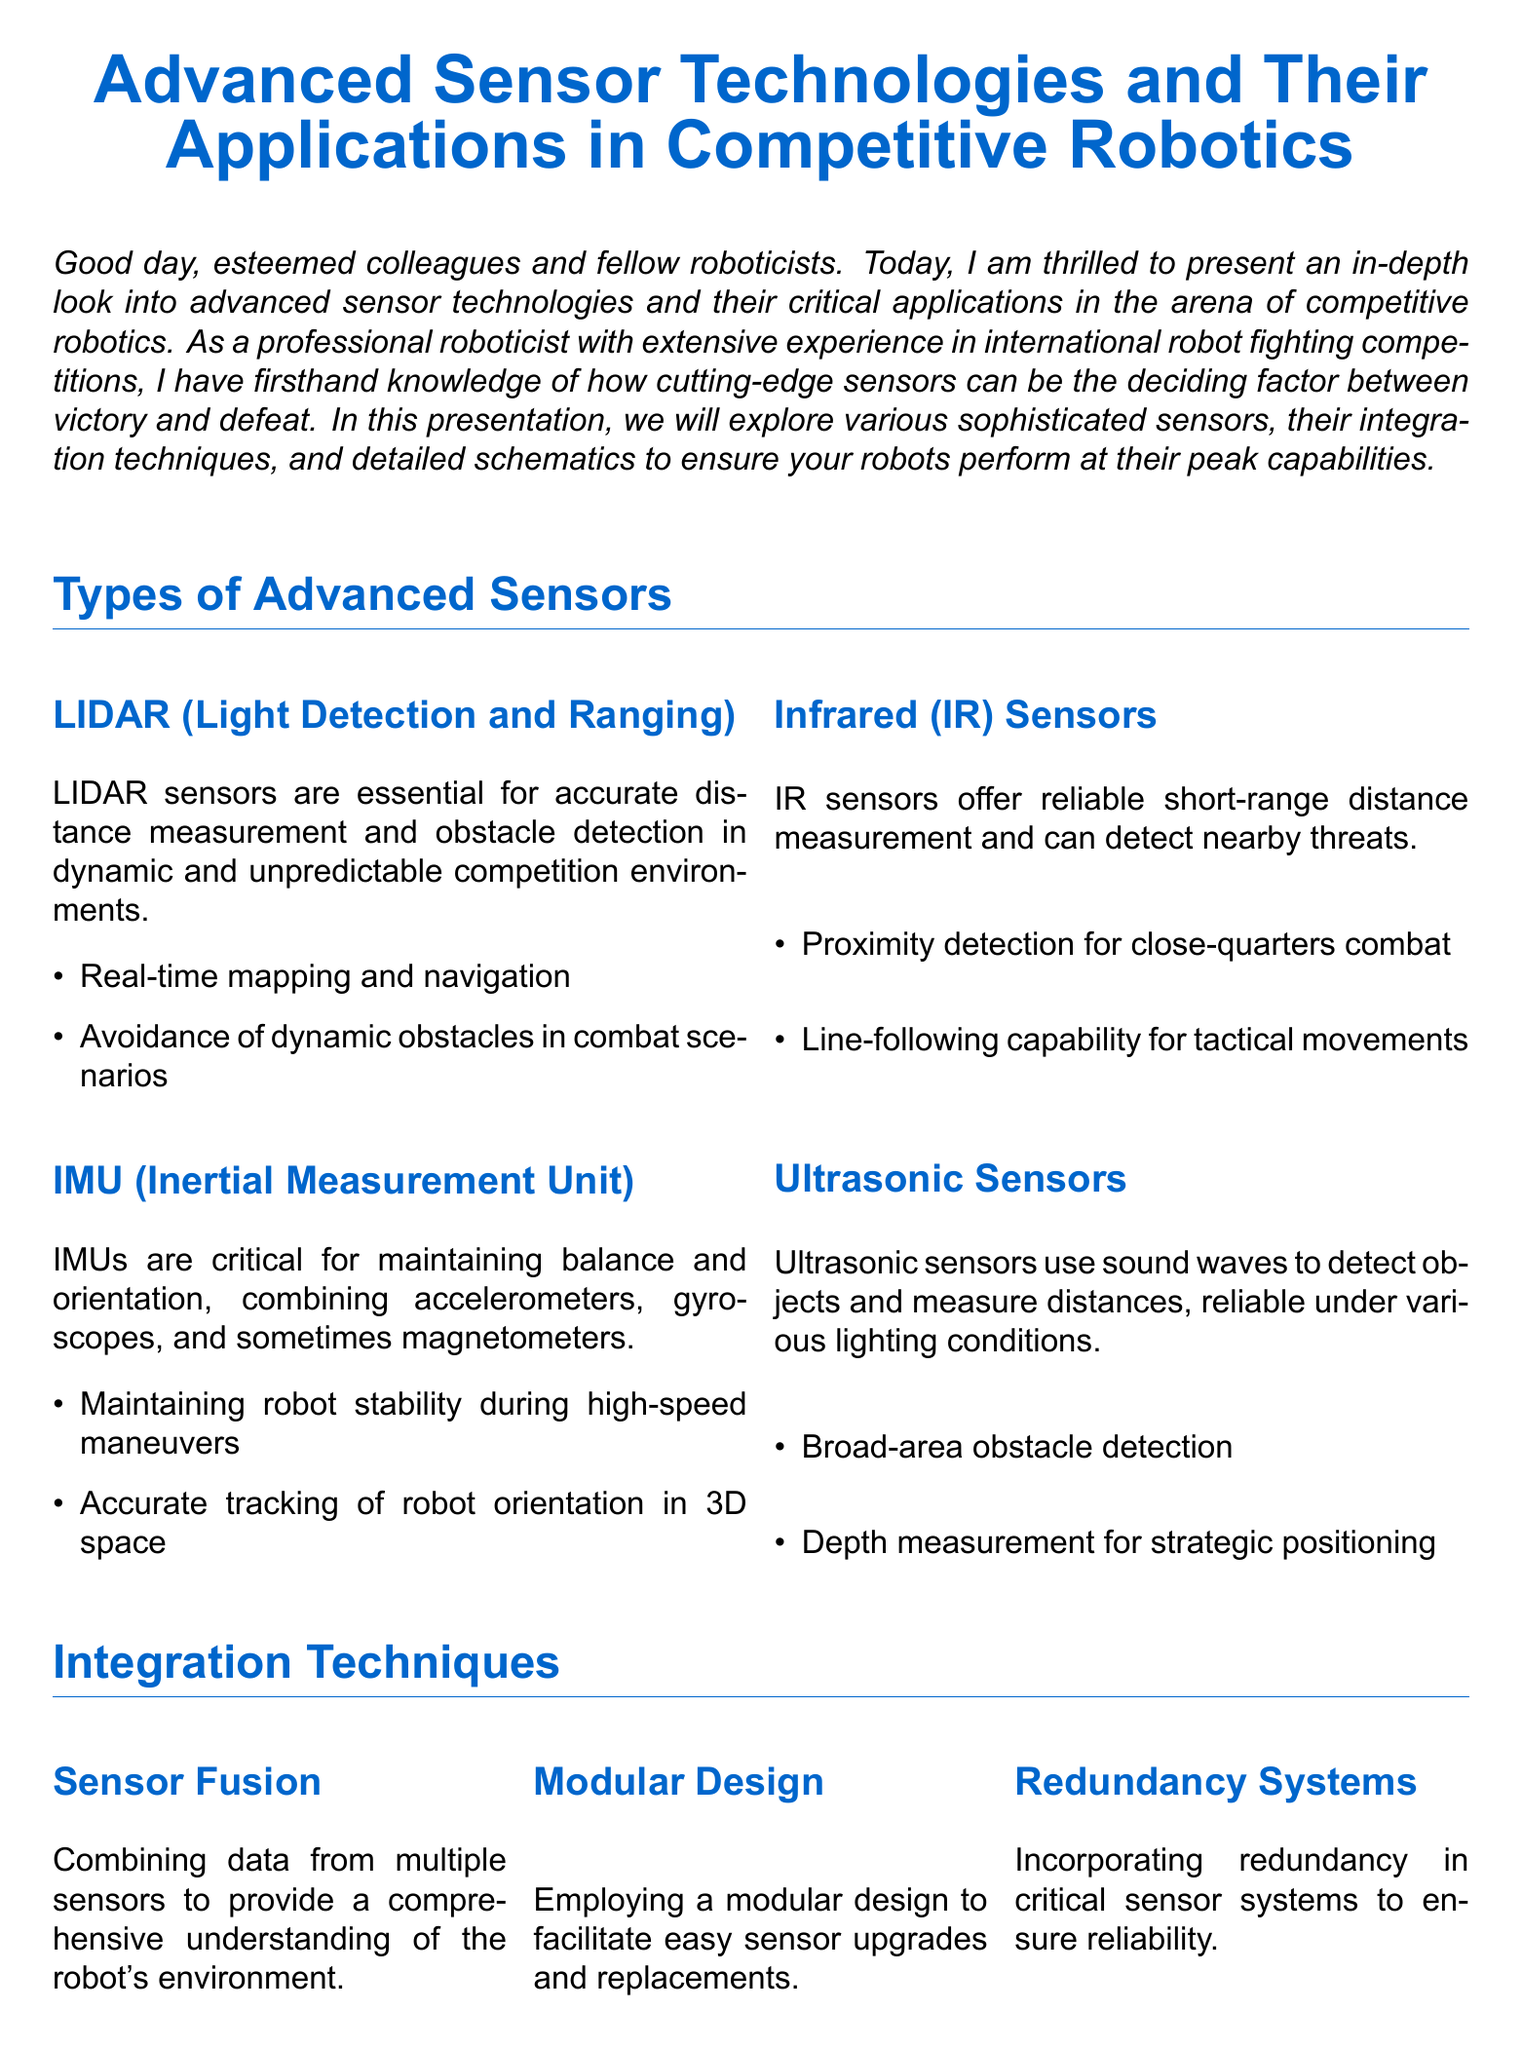what are the two sensors utilized by Team HyperShock? Team HyperShock utilizes LIDAR and IMU sensors to enhance their robot's performance in combat.
Answer: LIDAR and IMU what function do IMUs serve in competitive robotics? IMUs are critical for maintaining balance and orientation, combining accelerometers, gyroscopes, and sometimes magnetometers.
Answer: Balance and orientation what is the main application of LIDAR sensors? LIDAR sensors are essential for accurate distance measurement and obstacle detection in dynamic and unpredictable competition environments.
Answer: Distance measurement and obstacle detection which sensor offers reliable short-range distance measurement? Infrared (IR) sensors offer reliable short-range distance measurement and can detect nearby threats.
Answer: Infrared (IR) sensors what is one advantage of employing a modular design in sensor integration? A modular design facilitates easy sensor upgrades and replacements, enhancing flexibility in robotic design.
Answer: Easy upgrades and replacements how many integration techniques are discussed in the presentation? The presentation discusses three integration techniques, highlighting their significance in the design of robotics.
Answer: Three what type of sensor is used for proximity detection in combat? Infrared (IR) sensors are used for proximity detection, allowing robots to identify nearby threats effectively.
Answer: Infrared (IR) sensors what technology is critical for the high-speed precision of Team HyperShock? The integration of LIDAR and IMU sensors provides Team HyperShock with high-speed precision and stable maneuvers.
Answer: LIDAR and IMU sensors what is the color used for section titles in the document? The color defined for section titles in the document is robot blue, which emphasizes section headings.
Answer: robot blue 